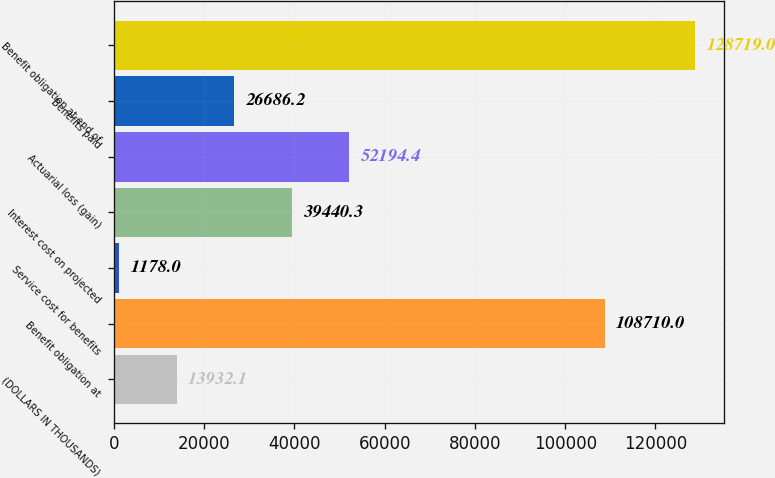Convert chart to OTSL. <chart><loc_0><loc_0><loc_500><loc_500><bar_chart><fcel>(DOLLARS IN THOUSANDS)<fcel>Benefit obligation at<fcel>Service cost for benefits<fcel>Interest cost on projected<fcel>Actuarial loss (gain)<fcel>Benefits paid<fcel>Benefit obligation at end of<nl><fcel>13932.1<fcel>108710<fcel>1178<fcel>39440.3<fcel>52194.4<fcel>26686.2<fcel>128719<nl></chart> 